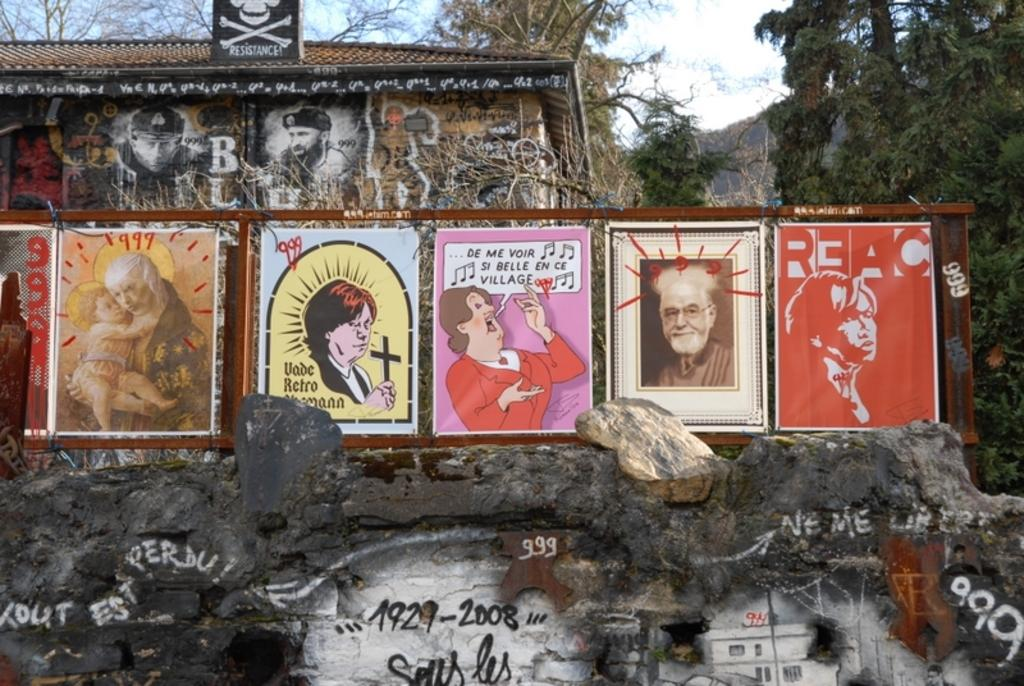What objects can be seen in the image? There are boards in the image. What is located at the bottom of the image? There is a wall at the bottom of the image. What is on the wall? Graffiti is present on the wall. What structure can be seen in the background of the image? There is a shed in the background of the image. What type of vegetation is visible in the background of the image? Trees are visible in the background of the image. What is visible at the top of the image? The sky is visible at the top of the image. What type of yam is being used to create the graffiti on the wall? There is no yam present in the image, and yams are not used for creating graffiti. 